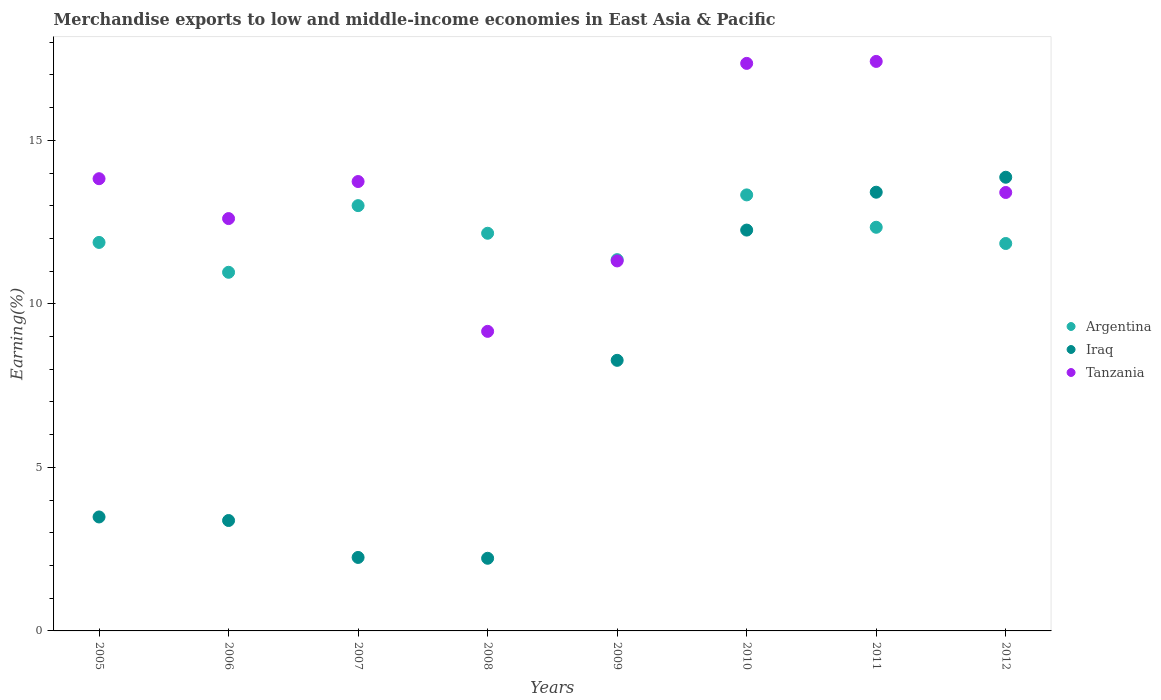Is the number of dotlines equal to the number of legend labels?
Keep it short and to the point. Yes. What is the percentage of amount earned from merchandise exports in Argentina in 2011?
Your answer should be very brief. 12.34. Across all years, what is the maximum percentage of amount earned from merchandise exports in Tanzania?
Provide a short and direct response. 17.41. Across all years, what is the minimum percentage of amount earned from merchandise exports in Iraq?
Your answer should be compact. 2.22. What is the total percentage of amount earned from merchandise exports in Tanzania in the graph?
Offer a terse response. 108.83. What is the difference between the percentage of amount earned from merchandise exports in Tanzania in 2009 and that in 2010?
Give a very brief answer. -6.04. What is the difference between the percentage of amount earned from merchandise exports in Argentina in 2005 and the percentage of amount earned from merchandise exports in Iraq in 2009?
Your answer should be very brief. 3.61. What is the average percentage of amount earned from merchandise exports in Tanzania per year?
Offer a terse response. 13.6. In the year 2011, what is the difference between the percentage of amount earned from merchandise exports in Tanzania and percentage of amount earned from merchandise exports in Iraq?
Keep it short and to the point. 4. What is the ratio of the percentage of amount earned from merchandise exports in Tanzania in 2008 to that in 2011?
Provide a succinct answer. 0.53. Is the difference between the percentage of amount earned from merchandise exports in Tanzania in 2009 and 2010 greater than the difference between the percentage of amount earned from merchandise exports in Iraq in 2009 and 2010?
Offer a very short reply. No. What is the difference between the highest and the second highest percentage of amount earned from merchandise exports in Argentina?
Give a very brief answer. 0.33. What is the difference between the highest and the lowest percentage of amount earned from merchandise exports in Tanzania?
Give a very brief answer. 8.25. Is the sum of the percentage of amount earned from merchandise exports in Tanzania in 2006 and 2008 greater than the maximum percentage of amount earned from merchandise exports in Iraq across all years?
Your answer should be compact. Yes. Is it the case that in every year, the sum of the percentage of amount earned from merchandise exports in Tanzania and percentage of amount earned from merchandise exports in Iraq  is greater than the percentage of amount earned from merchandise exports in Argentina?
Offer a terse response. No. Is the percentage of amount earned from merchandise exports in Argentina strictly less than the percentage of amount earned from merchandise exports in Tanzania over the years?
Keep it short and to the point. No. How many dotlines are there?
Your response must be concise. 3. Does the graph contain any zero values?
Offer a terse response. No. Does the graph contain grids?
Give a very brief answer. No. How many legend labels are there?
Provide a succinct answer. 3. How are the legend labels stacked?
Make the answer very short. Vertical. What is the title of the graph?
Keep it short and to the point. Merchandise exports to low and middle-income economies in East Asia & Pacific. What is the label or title of the X-axis?
Provide a short and direct response. Years. What is the label or title of the Y-axis?
Offer a very short reply. Earning(%). What is the Earning(%) in Argentina in 2005?
Provide a succinct answer. 11.88. What is the Earning(%) of Iraq in 2005?
Your response must be concise. 3.48. What is the Earning(%) in Tanzania in 2005?
Ensure brevity in your answer.  13.83. What is the Earning(%) of Argentina in 2006?
Provide a succinct answer. 10.97. What is the Earning(%) of Iraq in 2006?
Your response must be concise. 3.38. What is the Earning(%) in Tanzania in 2006?
Offer a very short reply. 12.61. What is the Earning(%) of Argentina in 2007?
Offer a terse response. 13. What is the Earning(%) in Iraq in 2007?
Your answer should be compact. 2.25. What is the Earning(%) in Tanzania in 2007?
Your answer should be very brief. 13.74. What is the Earning(%) of Argentina in 2008?
Give a very brief answer. 12.16. What is the Earning(%) in Iraq in 2008?
Provide a succinct answer. 2.22. What is the Earning(%) in Tanzania in 2008?
Give a very brief answer. 9.16. What is the Earning(%) of Argentina in 2009?
Give a very brief answer. 11.35. What is the Earning(%) in Iraq in 2009?
Provide a succinct answer. 8.27. What is the Earning(%) in Tanzania in 2009?
Your response must be concise. 11.31. What is the Earning(%) in Argentina in 2010?
Give a very brief answer. 13.33. What is the Earning(%) in Iraq in 2010?
Provide a succinct answer. 12.26. What is the Earning(%) of Tanzania in 2010?
Provide a succinct answer. 17.35. What is the Earning(%) of Argentina in 2011?
Your answer should be compact. 12.34. What is the Earning(%) of Iraq in 2011?
Offer a terse response. 13.41. What is the Earning(%) of Tanzania in 2011?
Ensure brevity in your answer.  17.41. What is the Earning(%) of Argentina in 2012?
Your answer should be compact. 11.85. What is the Earning(%) in Iraq in 2012?
Offer a terse response. 13.87. What is the Earning(%) of Tanzania in 2012?
Keep it short and to the point. 13.41. Across all years, what is the maximum Earning(%) of Argentina?
Your answer should be compact. 13.33. Across all years, what is the maximum Earning(%) of Iraq?
Keep it short and to the point. 13.87. Across all years, what is the maximum Earning(%) in Tanzania?
Provide a succinct answer. 17.41. Across all years, what is the minimum Earning(%) in Argentina?
Your answer should be very brief. 10.97. Across all years, what is the minimum Earning(%) in Iraq?
Provide a short and direct response. 2.22. Across all years, what is the minimum Earning(%) of Tanzania?
Make the answer very short. 9.16. What is the total Earning(%) of Argentina in the graph?
Your answer should be very brief. 96.89. What is the total Earning(%) in Iraq in the graph?
Keep it short and to the point. 59.15. What is the total Earning(%) of Tanzania in the graph?
Your answer should be very brief. 108.83. What is the difference between the Earning(%) in Argentina in 2005 and that in 2006?
Provide a short and direct response. 0.91. What is the difference between the Earning(%) in Iraq in 2005 and that in 2006?
Give a very brief answer. 0.11. What is the difference between the Earning(%) of Tanzania in 2005 and that in 2006?
Ensure brevity in your answer.  1.22. What is the difference between the Earning(%) of Argentina in 2005 and that in 2007?
Your answer should be very brief. -1.13. What is the difference between the Earning(%) in Iraq in 2005 and that in 2007?
Provide a short and direct response. 1.24. What is the difference between the Earning(%) in Tanzania in 2005 and that in 2007?
Offer a terse response. 0.09. What is the difference between the Earning(%) in Argentina in 2005 and that in 2008?
Ensure brevity in your answer.  -0.28. What is the difference between the Earning(%) in Iraq in 2005 and that in 2008?
Provide a succinct answer. 1.26. What is the difference between the Earning(%) of Tanzania in 2005 and that in 2008?
Offer a very short reply. 4.67. What is the difference between the Earning(%) in Argentina in 2005 and that in 2009?
Offer a terse response. 0.53. What is the difference between the Earning(%) in Iraq in 2005 and that in 2009?
Offer a very short reply. -4.79. What is the difference between the Earning(%) in Tanzania in 2005 and that in 2009?
Your response must be concise. 2.51. What is the difference between the Earning(%) of Argentina in 2005 and that in 2010?
Offer a very short reply. -1.45. What is the difference between the Earning(%) in Iraq in 2005 and that in 2010?
Keep it short and to the point. -8.77. What is the difference between the Earning(%) of Tanzania in 2005 and that in 2010?
Provide a succinct answer. -3.53. What is the difference between the Earning(%) in Argentina in 2005 and that in 2011?
Ensure brevity in your answer.  -0.46. What is the difference between the Earning(%) in Iraq in 2005 and that in 2011?
Your response must be concise. -9.93. What is the difference between the Earning(%) of Tanzania in 2005 and that in 2011?
Your response must be concise. -3.59. What is the difference between the Earning(%) of Argentina in 2005 and that in 2012?
Keep it short and to the point. 0.03. What is the difference between the Earning(%) in Iraq in 2005 and that in 2012?
Your response must be concise. -10.39. What is the difference between the Earning(%) of Tanzania in 2005 and that in 2012?
Your answer should be compact. 0.42. What is the difference between the Earning(%) of Argentina in 2006 and that in 2007?
Ensure brevity in your answer.  -2.04. What is the difference between the Earning(%) of Iraq in 2006 and that in 2007?
Ensure brevity in your answer.  1.13. What is the difference between the Earning(%) in Tanzania in 2006 and that in 2007?
Your answer should be compact. -1.13. What is the difference between the Earning(%) of Argentina in 2006 and that in 2008?
Offer a very short reply. -1.19. What is the difference between the Earning(%) in Iraq in 2006 and that in 2008?
Provide a succinct answer. 1.15. What is the difference between the Earning(%) of Tanzania in 2006 and that in 2008?
Give a very brief answer. 3.45. What is the difference between the Earning(%) of Argentina in 2006 and that in 2009?
Offer a terse response. -0.39. What is the difference between the Earning(%) in Iraq in 2006 and that in 2009?
Provide a succinct answer. -4.9. What is the difference between the Earning(%) of Tanzania in 2006 and that in 2009?
Your response must be concise. 1.3. What is the difference between the Earning(%) of Argentina in 2006 and that in 2010?
Keep it short and to the point. -2.37. What is the difference between the Earning(%) in Iraq in 2006 and that in 2010?
Give a very brief answer. -8.88. What is the difference between the Earning(%) of Tanzania in 2006 and that in 2010?
Your answer should be very brief. -4.75. What is the difference between the Earning(%) of Argentina in 2006 and that in 2011?
Give a very brief answer. -1.38. What is the difference between the Earning(%) in Iraq in 2006 and that in 2011?
Your answer should be very brief. -10.04. What is the difference between the Earning(%) in Tanzania in 2006 and that in 2011?
Your answer should be compact. -4.81. What is the difference between the Earning(%) in Argentina in 2006 and that in 2012?
Your answer should be very brief. -0.88. What is the difference between the Earning(%) of Iraq in 2006 and that in 2012?
Offer a terse response. -10.5. What is the difference between the Earning(%) of Tanzania in 2006 and that in 2012?
Make the answer very short. -0.8. What is the difference between the Earning(%) of Argentina in 2007 and that in 2008?
Make the answer very short. 0.84. What is the difference between the Earning(%) of Iraq in 2007 and that in 2008?
Keep it short and to the point. 0.03. What is the difference between the Earning(%) of Tanzania in 2007 and that in 2008?
Give a very brief answer. 4.58. What is the difference between the Earning(%) in Argentina in 2007 and that in 2009?
Offer a terse response. 1.65. What is the difference between the Earning(%) of Iraq in 2007 and that in 2009?
Your response must be concise. -6.03. What is the difference between the Earning(%) in Tanzania in 2007 and that in 2009?
Offer a terse response. 2.43. What is the difference between the Earning(%) of Argentina in 2007 and that in 2010?
Keep it short and to the point. -0.33. What is the difference between the Earning(%) in Iraq in 2007 and that in 2010?
Offer a terse response. -10.01. What is the difference between the Earning(%) of Tanzania in 2007 and that in 2010?
Give a very brief answer. -3.61. What is the difference between the Earning(%) of Argentina in 2007 and that in 2011?
Offer a very short reply. 0.66. What is the difference between the Earning(%) of Iraq in 2007 and that in 2011?
Offer a very short reply. -11.17. What is the difference between the Earning(%) in Tanzania in 2007 and that in 2011?
Offer a very short reply. -3.67. What is the difference between the Earning(%) in Argentina in 2007 and that in 2012?
Provide a succinct answer. 1.16. What is the difference between the Earning(%) in Iraq in 2007 and that in 2012?
Keep it short and to the point. -11.63. What is the difference between the Earning(%) in Tanzania in 2007 and that in 2012?
Your answer should be very brief. 0.33. What is the difference between the Earning(%) of Argentina in 2008 and that in 2009?
Provide a succinct answer. 0.81. What is the difference between the Earning(%) in Iraq in 2008 and that in 2009?
Offer a terse response. -6.05. What is the difference between the Earning(%) in Tanzania in 2008 and that in 2009?
Your answer should be compact. -2.15. What is the difference between the Earning(%) in Argentina in 2008 and that in 2010?
Keep it short and to the point. -1.17. What is the difference between the Earning(%) of Iraq in 2008 and that in 2010?
Your answer should be compact. -10.04. What is the difference between the Earning(%) of Tanzania in 2008 and that in 2010?
Provide a short and direct response. -8.19. What is the difference between the Earning(%) in Argentina in 2008 and that in 2011?
Keep it short and to the point. -0.18. What is the difference between the Earning(%) in Iraq in 2008 and that in 2011?
Offer a very short reply. -11.19. What is the difference between the Earning(%) of Tanzania in 2008 and that in 2011?
Your answer should be very brief. -8.25. What is the difference between the Earning(%) in Argentina in 2008 and that in 2012?
Give a very brief answer. 0.31. What is the difference between the Earning(%) in Iraq in 2008 and that in 2012?
Keep it short and to the point. -11.65. What is the difference between the Earning(%) in Tanzania in 2008 and that in 2012?
Ensure brevity in your answer.  -4.25. What is the difference between the Earning(%) in Argentina in 2009 and that in 2010?
Your response must be concise. -1.98. What is the difference between the Earning(%) of Iraq in 2009 and that in 2010?
Offer a terse response. -3.98. What is the difference between the Earning(%) in Tanzania in 2009 and that in 2010?
Provide a succinct answer. -6.04. What is the difference between the Earning(%) in Argentina in 2009 and that in 2011?
Your response must be concise. -0.99. What is the difference between the Earning(%) of Iraq in 2009 and that in 2011?
Offer a very short reply. -5.14. What is the difference between the Earning(%) of Tanzania in 2009 and that in 2011?
Ensure brevity in your answer.  -6.1. What is the difference between the Earning(%) of Argentina in 2009 and that in 2012?
Ensure brevity in your answer.  -0.49. What is the difference between the Earning(%) of Iraq in 2009 and that in 2012?
Your answer should be very brief. -5.6. What is the difference between the Earning(%) of Tanzania in 2009 and that in 2012?
Your answer should be compact. -2.09. What is the difference between the Earning(%) of Iraq in 2010 and that in 2011?
Your response must be concise. -1.16. What is the difference between the Earning(%) in Tanzania in 2010 and that in 2011?
Your answer should be compact. -0.06. What is the difference between the Earning(%) of Argentina in 2010 and that in 2012?
Your response must be concise. 1.49. What is the difference between the Earning(%) in Iraq in 2010 and that in 2012?
Give a very brief answer. -1.62. What is the difference between the Earning(%) of Tanzania in 2010 and that in 2012?
Provide a short and direct response. 3.95. What is the difference between the Earning(%) of Argentina in 2011 and that in 2012?
Make the answer very short. 0.5. What is the difference between the Earning(%) of Iraq in 2011 and that in 2012?
Your answer should be very brief. -0.46. What is the difference between the Earning(%) in Tanzania in 2011 and that in 2012?
Keep it short and to the point. 4.01. What is the difference between the Earning(%) of Argentina in 2005 and the Earning(%) of Iraq in 2006?
Your answer should be compact. 8.5. What is the difference between the Earning(%) in Argentina in 2005 and the Earning(%) in Tanzania in 2006?
Your answer should be very brief. -0.73. What is the difference between the Earning(%) of Iraq in 2005 and the Earning(%) of Tanzania in 2006?
Provide a succinct answer. -9.12. What is the difference between the Earning(%) of Argentina in 2005 and the Earning(%) of Iraq in 2007?
Offer a terse response. 9.63. What is the difference between the Earning(%) of Argentina in 2005 and the Earning(%) of Tanzania in 2007?
Ensure brevity in your answer.  -1.86. What is the difference between the Earning(%) of Iraq in 2005 and the Earning(%) of Tanzania in 2007?
Your answer should be very brief. -10.26. What is the difference between the Earning(%) of Argentina in 2005 and the Earning(%) of Iraq in 2008?
Your answer should be compact. 9.66. What is the difference between the Earning(%) in Argentina in 2005 and the Earning(%) in Tanzania in 2008?
Keep it short and to the point. 2.72. What is the difference between the Earning(%) of Iraq in 2005 and the Earning(%) of Tanzania in 2008?
Your answer should be very brief. -5.68. What is the difference between the Earning(%) in Argentina in 2005 and the Earning(%) in Iraq in 2009?
Offer a terse response. 3.61. What is the difference between the Earning(%) of Argentina in 2005 and the Earning(%) of Tanzania in 2009?
Offer a terse response. 0.57. What is the difference between the Earning(%) in Iraq in 2005 and the Earning(%) in Tanzania in 2009?
Provide a succinct answer. -7.83. What is the difference between the Earning(%) in Argentina in 2005 and the Earning(%) in Iraq in 2010?
Your response must be concise. -0.38. What is the difference between the Earning(%) of Argentina in 2005 and the Earning(%) of Tanzania in 2010?
Your response must be concise. -5.47. What is the difference between the Earning(%) in Iraq in 2005 and the Earning(%) in Tanzania in 2010?
Give a very brief answer. -13.87. What is the difference between the Earning(%) in Argentina in 2005 and the Earning(%) in Iraq in 2011?
Your response must be concise. -1.54. What is the difference between the Earning(%) in Argentina in 2005 and the Earning(%) in Tanzania in 2011?
Give a very brief answer. -5.53. What is the difference between the Earning(%) in Iraq in 2005 and the Earning(%) in Tanzania in 2011?
Provide a short and direct response. -13.93. What is the difference between the Earning(%) in Argentina in 2005 and the Earning(%) in Iraq in 2012?
Your response must be concise. -1.99. What is the difference between the Earning(%) in Argentina in 2005 and the Earning(%) in Tanzania in 2012?
Give a very brief answer. -1.53. What is the difference between the Earning(%) of Iraq in 2005 and the Earning(%) of Tanzania in 2012?
Provide a succinct answer. -9.92. What is the difference between the Earning(%) in Argentina in 2006 and the Earning(%) in Iraq in 2007?
Offer a very short reply. 8.72. What is the difference between the Earning(%) in Argentina in 2006 and the Earning(%) in Tanzania in 2007?
Make the answer very short. -2.77. What is the difference between the Earning(%) in Iraq in 2006 and the Earning(%) in Tanzania in 2007?
Your answer should be very brief. -10.37. What is the difference between the Earning(%) of Argentina in 2006 and the Earning(%) of Iraq in 2008?
Keep it short and to the point. 8.75. What is the difference between the Earning(%) of Argentina in 2006 and the Earning(%) of Tanzania in 2008?
Offer a very short reply. 1.81. What is the difference between the Earning(%) in Iraq in 2006 and the Earning(%) in Tanzania in 2008?
Make the answer very short. -5.78. What is the difference between the Earning(%) of Argentina in 2006 and the Earning(%) of Iraq in 2009?
Provide a short and direct response. 2.69. What is the difference between the Earning(%) in Argentina in 2006 and the Earning(%) in Tanzania in 2009?
Your answer should be compact. -0.35. What is the difference between the Earning(%) of Iraq in 2006 and the Earning(%) of Tanzania in 2009?
Your response must be concise. -7.94. What is the difference between the Earning(%) in Argentina in 2006 and the Earning(%) in Iraq in 2010?
Provide a short and direct response. -1.29. What is the difference between the Earning(%) of Argentina in 2006 and the Earning(%) of Tanzania in 2010?
Keep it short and to the point. -6.39. What is the difference between the Earning(%) in Iraq in 2006 and the Earning(%) in Tanzania in 2010?
Offer a terse response. -13.98. What is the difference between the Earning(%) of Argentina in 2006 and the Earning(%) of Iraq in 2011?
Offer a very short reply. -2.45. What is the difference between the Earning(%) of Argentina in 2006 and the Earning(%) of Tanzania in 2011?
Provide a succinct answer. -6.45. What is the difference between the Earning(%) in Iraq in 2006 and the Earning(%) in Tanzania in 2011?
Keep it short and to the point. -14.04. What is the difference between the Earning(%) of Argentina in 2006 and the Earning(%) of Iraq in 2012?
Give a very brief answer. -2.91. What is the difference between the Earning(%) in Argentina in 2006 and the Earning(%) in Tanzania in 2012?
Your answer should be very brief. -2.44. What is the difference between the Earning(%) in Iraq in 2006 and the Earning(%) in Tanzania in 2012?
Give a very brief answer. -10.03. What is the difference between the Earning(%) of Argentina in 2007 and the Earning(%) of Iraq in 2008?
Make the answer very short. 10.78. What is the difference between the Earning(%) in Argentina in 2007 and the Earning(%) in Tanzania in 2008?
Give a very brief answer. 3.84. What is the difference between the Earning(%) of Iraq in 2007 and the Earning(%) of Tanzania in 2008?
Ensure brevity in your answer.  -6.91. What is the difference between the Earning(%) of Argentina in 2007 and the Earning(%) of Iraq in 2009?
Offer a terse response. 4.73. What is the difference between the Earning(%) in Argentina in 2007 and the Earning(%) in Tanzania in 2009?
Provide a succinct answer. 1.69. What is the difference between the Earning(%) in Iraq in 2007 and the Earning(%) in Tanzania in 2009?
Keep it short and to the point. -9.07. What is the difference between the Earning(%) in Argentina in 2007 and the Earning(%) in Iraq in 2010?
Your answer should be very brief. 0.75. What is the difference between the Earning(%) in Argentina in 2007 and the Earning(%) in Tanzania in 2010?
Ensure brevity in your answer.  -4.35. What is the difference between the Earning(%) of Iraq in 2007 and the Earning(%) of Tanzania in 2010?
Offer a terse response. -15.11. What is the difference between the Earning(%) of Argentina in 2007 and the Earning(%) of Iraq in 2011?
Give a very brief answer. -0.41. What is the difference between the Earning(%) of Argentina in 2007 and the Earning(%) of Tanzania in 2011?
Give a very brief answer. -4.41. What is the difference between the Earning(%) in Iraq in 2007 and the Earning(%) in Tanzania in 2011?
Provide a succinct answer. -15.17. What is the difference between the Earning(%) in Argentina in 2007 and the Earning(%) in Iraq in 2012?
Offer a very short reply. -0.87. What is the difference between the Earning(%) of Argentina in 2007 and the Earning(%) of Tanzania in 2012?
Offer a terse response. -0.4. What is the difference between the Earning(%) in Iraq in 2007 and the Earning(%) in Tanzania in 2012?
Your response must be concise. -11.16. What is the difference between the Earning(%) in Argentina in 2008 and the Earning(%) in Iraq in 2009?
Keep it short and to the point. 3.89. What is the difference between the Earning(%) in Argentina in 2008 and the Earning(%) in Tanzania in 2009?
Your answer should be compact. 0.85. What is the difference between the Earning(%) in Iraq in 2008 and the Earning(%) in Tanzania in 2009?
Offer a very short reply. -9.09. What is the difference between the Earning(%) of Argentina in 2008 and the Earning(%) of Iraq in 2010?
Your answer should be very brief. -0.1. What is the difference between the Earning(%) in Argentina in 2008 and the Earning(%) in Tanzania in 2010?
Your response must be concise. -5.19. What is the difference between the Earning(%) of Iraq in 2008 and the Earning(%) of Tanzania in 2010?
Provide a succinct answer. -15.13. What is the difference between the Earning(%) in Argentina in 2008 and the Earning(%) in Iraq in 2011?
Your answer should be compact. -1.25. What is the difference between the Earning(%) in Argentina in 2008 and the Earning(%) in Tanzania in 2011?
Ensure brevity in your answer.  -5.25. What is the difference between the Earning(%) of Iraq in 2008 and the Earning(%) of Tanzania in 2011?
Your response must be concise. -15.19. What is the difference between the Earning(%) of Argentina in 2008 and the Earning(%) of Iraq in 2012?
Your answer should be compact. -1.71. What is the difference between the Earning(%) of Argentina in 2008 and the Earning(%) of Tanzania in 2012?
Make the answer very short. -1.25. What is the difference between the Earning(%) in Iraq in 2008 and the Earning(%) in Tanzania in 2012?
Your answer should be very brief. -11.19. What is the difference between the Earning(%) in Argentina in 2009 and the Earning(%) in Iraq in 2010?
Give a very brief answer. -0.9. What is the difference between the Earning(%) of Argentina in 2009 and the Earning(%) of Tanzania in 2010?
Offer a terse response. -6. What is the difference between the Earning(%) of Iraq in 2009 and the Earning(%) of Tanzania in 2010?
Keep it short and to the point. -9.08. What is the difference between the Earning(%) in Argentina in 2009 and the Earning(%) in Iraq in 2011?
Give a very brief answer. -2.06. What is the difference between the Earning(%) of Argentina in 2009 and the Earning(%) of Tanzania in 2011?
Offer a very short reply. -6.06. What is the difference between the Earning(%) in Iraq in 2009 and the Earning(%) in Tanzania in 2011?
Make the answer very short. -9.14. What is the difference between the Earning(%) in Argentina in 2009 and the Earning(%) in Iraq in 2012?
Make the answer very short. -2.52. What is the difference between the Earning(%) in Argentina in 2009 and the Earning(%) in Tanzania in 2012?
Provide a short and direct response. -2.05. What is the difference between the Earning(%) of Iraq in 2009 and the Earning(%) of Tanzania in 2012?
Ensure brevity in your answer.  -5.13. What is the difference between the Earning(%) of Argentina in 2010 and the Earning(%) of Iraq in 2011?
Your answer should be very brief. -0.08. What is the difference between the Earning(%) in Argentina in 2010 and the Earning(%) in Tanzania in 2011?
Your answer should be very brief. -4.08. What is the difference between the Earning(%) in Iraq in 2010 and the Earning(%) in Tanzania in 2011?
Your answer should be very brief. -5.16. What is the difference between the Earning(%) in Argentina in 2010 and the Earning(%) in Iraq in 2012?
Give a very brief answer. -0.54. What is the difference between the Earning(%) in Argentina in 2010 and the Earning(%) in Tanzania in 2012?
Offer a very short reply. -0.07. What is the difference between the Earning(%) in Iraq in 2010 and the Earning(%) in Tanzania in 2012?
Make the answer very short. -1.15. What is the difference between the Earning(%) of Argentina in 2011 and the Earning(%) of Iraq in 2012?
Ensure brevity in your answer.  -1.53. What is the difference between the Earning(%) in Argentina in 2011 and the Earning(%) in Tanzania in 2012?
Offer a terse response. -1.06. What is the difference between the Earning(%) of Iraq in 2011 and the Earning(%) of Tanzania in 2012?
Keep it short and to the point. 0.01. What is the average Earning(%) in Argentina per year?
Ensure brevity in your answer.  12.11. What is the average Earning(%) in Iraq per year?
Ensure brevity in your answer.  7.39. What is the average Earning(%) of Tanzania per year?
Give a very brief answer. 13.6. In the year 2005, what is the difference between the Earning(%) of Argentina and Earning(%) of Iraq?
Your answer should be very brief. 8.39. In the year 2005, what is the difference between the Earning(%) of Argentina and Earning(%) of Tanzania?
Keep it short and to the point. -1.95. In the year 2005, what is the difference between the Earning(%) of Iraq and Earning(%) of Tanzania?
Provide a succinct answer. -10.34. In the year 2006, what is the difference between the Earning(%) in Argentina and Earning(%) in Iraq?
Offer a very short reply. 7.59. In the year 2006, what is the difference between the Earning(%) of Argentina and Earning(%) of Tanzania?
Your answer should be compact. -1.64. In the year 2006, what is the difference between the Earning(%) of Iraq and Earning(%) of Tanzania?
Ensure brevity in your answer.  -9.23. In the year 2007, what is the difference between the Earning(%) of Argentina and Earning(%) of Iraq?
Your answer should be very brief. 10.76. In the year 2007, what is the difference between the Earning(%) in Argentina and Earning(%) in Tanzania?
Keep it short and to the point. -0.74. In the year 2007, what is the difference between the Earning(%) in Iraq and Earning(%) in Tanzania?
Provide a succinct answer. -11.49. In the year 2008, what is the difference between the Earning(%) in Argentina and Earning(%) in Iraq?
Offer a terse response. 9.94. In the year 2008, what is the difference between the Earning(%) in Argentina and Earning(%) in Tanzania?
Keep it short and to the point. 3. In the year 2008, what is the difference between the Earning(%) in Iraq and Earning(%) in Tanzania?
Your answer should be very brief. -6.94. In the year 2009, what is the difference between the Earning(%) of Argentina and Earning(%) of Iraq?
Provide a short and direct response. 3.08. In the year 2009, what is the difference between the Earning(%) in Argentina and Earning(%) in Tanzania?
Offer a terse response. 0.04. In the year 2009, what is the difference between the Earning(%) in Iraq and Earning(%) in Tanzania?
Offer a terse response. -3.04. In the year 2010, what is the difference between the Earning(%) in Argentina and Earning(%) in Iraq?
Offer a very short reply. 1.08. In the year 2010, what is the difference between the Earning(%) in Argentina and Earning(%) in Tanzania?
Make the answer very short. -4.02. In the year 2010, what is the difference between the Earning(%) in Iraq and Earning(%) in Tanzania?
Offer a very short reply. -5.1. In the year 2011, what is the difference between the Earning(%) of Argentina and Earning(%) of Iraq?
Your response must be concise. -1.07. In the year 2011, what is the difference between the Earning(%) in Argentina and Earning(%) in Tanzania?
Provide a short and direct response. -5.07. In the year 2011, what is the difference between the Earning(%) of Iraq and Earning(%) of Tanzania?
Offer a very short reply. -4. In the year 2012, what is the difference between the Earning(%) of Argentina and Earning(%) of Iraq?
Offer a very short reply. -2.03. In the year 2012, what is the difference between the Earning(%) in Argentina and Earning(%) in Tanzania?
Offer a terse response. -1.56. In the year 2012, what is the difference between the Earning(%) in Iraq and Earning(%) in Tanzania?
Make the answer very short. 0.47. What is the ratio of the Earning(%) in Argentina in 2005 to that in 2006?
Your answer should be very brief. 1.08. What is the ratio of the Earning(%) in Iraq in 2005 to that in 2006?
Your answer should be very brief. 1.03. What is the ratio of the Earning(%) in Tanzania in 2005 to that in 2006?
Keep it short and to the point. 1.1. What is the ratio of the Earning(%) of Argentina in 2005 to that in 2007?
Give a very brief answer. 0.91. What is the ratio of the Earning(%) in Iraq in 2005 to that in 2007?
Offer a terse response. 1.55. What is the ratio of the Earning(%) in Argentina in 2005 to that in 2008?
Ensure brevity in your answer.  0.98. What is the ratio of the Earning(%) of Iraq in 2005 to that in 2008?
Your response must be concise. 1.57. What is the ratio of the Earning(%) of Tanzania in 2005 to that in 2008?
Your answer should be very brief. 1.51. What is the ratio of the Earning(%) of Argentina in 2005 to that in 2009?
Your response must be concise. 1.05. What is the ratio of the Earning(%) in Iraq in 2005 to that in 2009?
Your answer should be very brief. 0.42. What is the ratio of the Earning(%) in Tanzania in 2005 to that in 2009?
Give a very brief answer. 1.22. What is the ratio of the Earning(%) of Argentina in 2005 to that in 2010?
Your answer should be very brief. 0.89. What is the ratio of the Earning(%) in Iraq in 2005 to that in 2010?
Keep it short and to the point. 0.28. What is the ratio of the Earning(%) of Tanzania in 2005 to that in 2010?
Offer a very short reply. 0.8. What is the ratio of the Earning(%) of Argentina in 2005 to that in 2011?
Give a very brief answer. 0.96. What is the ratio of the Earning(%) of Iraq in 2005 to that in 2011?
Your answer should be compact. 0.26. What is the ratio of the Earning(%) of Tanzania in 2005 to that in 2011?
Give a very brief answer. 0.79. What is the ratio of the Earning(%) in Argentina in 2005 to that in 2012?
Your response must be concise. 1. What is the ratio of the Earning(%) in Iraq in 2005 to that in 2012?
Ensure brevity in your answer.  0.25. What is the ratio of the Earning(%) of Tanzania in 2005 to that in 2012?
Offer a terse response. 1.03. What is the ratio of the Earning(%) of Argentina in 2006 to that in 2007?
Give a very brief answer. 0.84. What is the ratio of the Earning(%) in Iraq in 2006 to that in 2007?
Keep it short and to the point. 1.5. What is the ratio of the Earning(%) of Tanzania in 2006 to that in 2007?
Give a very brief answer. 0.92. What is the ratio of the Earning(%) of Argentina in 2006 to that in 2008?
Provide a short and direct response. 0.9. What is the ratio of the Earning(%) in Iraq in 2006 to that in 2008?
Ensure brevity in your answer.  1.52. What is the ratio of the Earning(%) in Tanzania in 2006 to that in 2008?
Offer a very short reply. 1.38. What is the ratio of the Earning(%) of Argentina in 2006 to that in 2009?
Provide a succinct answer. 0.97. What is the ratio of the Earning(%) in Iraq in 2006 to that in 2009?
Your answer should be compact. 0.41. What is the ratio of the Earning(%) in Tanzania in 2006 to that in 2009?
Your answer should be compact. 1.11. What is the ratio of the Earning(%) of Argentina in 2006 to that in 2010?
Keep it short and to the point. 0.82. What is the ratio of the Earning(%) of Iraq in 2006 to that in 2010?
Provide a succinct answer. 0.28. What is the ratio of the Earning(%) in Tanzania in 2006 to that in 2010?
Your answer should be very brief. 0.73. What is the ratio of the Earning(%) in Argentina in 2006 to that in 2011?
Make the answer very short. 0.89. What is the ratio of the Earning(%) of Iraq in 2006 to that in 2011?
Offer a terse response. 0.25. What is the ratio of the Earning(%) of Tanzania in 2006 to that in 2011?
Ensure brevity in your answer.  0.72. What is the ratio of the Earning(%) in Argentina in 2006 to that in 2012?
Make the answer very short. 0.93. What is the ratio of the Earning(%) of Iraq in 2006 to that in 2012?
Offer a very short reply. 0.24. What is the ratio of the Earning(%) in Tanzania in 2006 to that in 2012?
Ensure brevity in your answer.  0.94. What is the ratio of the Earning(%) of Argentina in 2007 to that in 2008?
Offer a very short reply. 1.07. What is the ratio of the Earning(%) in Iraq in 2007 to that in 2008?
Ensure brevity in your answer.  1.01. What is the ratio of the Earning(%) in Tanzania in 2007 to that in 2008?
Give a very brief answer. 1.5. What is the ratio of the Earning(%) of Argentina in 2007 to that in 2009?
Provide a succinct answer. 1.15. What is the ratio of the Earning(%) in Iraq in 2007 to that in 2009?
Your response must be concise. 0.27. What is the ratio of the Earning(%) of Tanzania in 2007 to that in 2009?
Offer a very short reply. 1.21. What is the ratio of the Earning(%) of Argentina in 2007 to that in 2010?
Keep it short and to the point. 0.98. What is the ratio of the Earning(%) of Iraq in 2007 to that in 2010?
Provide a succinct answer. 0.18. What is the ratio of the Earning(%) in Tanzania in 2007 to that in 2010?
Keep it short and to the point. 0.79. What is the ratio of the Earning(%) in Argentina in 2007 to that in 2011?
Your answer should be compact. 1.05. What is the ratio of the Earning(%) in Iraq in 2007 to that in 2011?
Keep it short and to the point. 0.17. What is the ratio of the Earning(%) of Tanzania in 2007 to that in 2011?
Provide a succinct answer. 0.79. What is the ratio of the Earning(%) in Argentina in 2007 to that in 2012?
Your answer should be compact. 1.1. What is the ratio of the Earning(%) in Iraq in 2007 to that in 2012?
Offer a very short reply. 0.16. What is the ratio of the Earning(%) in Tanzania in 2007 to that in 2012?
Ensure brevity in your answer.  1.02. What is the ratio of the Earning(%) in Argentina in 2008 to that in 2009?
Provide a short and direct response. 1.07. What is the ratio of the Earning(%) of Iraq in 2008 to that in 2009?
Your response must be concise. 0.27. What is the ratio of the Earning(%) of Tanzania in 2008 to that in 2009?
Give a very brief answer. 0.81. What is the ratio of the Earning(%) in Argentina in 2008 to that in 2010?
Keep it short and to the point. 0.91. What is the ratio of the Earning(%) of Iraq in 2008 to that in 2010?
Your answer should be very brief. 0.18. What is the ratio of the Earning(%) in Tanzania in 2008 to that in 2010?
Your answer should be compact. 0.53. What is the ratio of the Earning(%) in Argentina in 2008 to that in 2011?
Make the answer very short. 0.99. What is the ratio of the Earning(%) in Iraq in 2008 to that in 2011?
Offer a very short reply. 0.17. What is the ratio of the Earning(%) of Tanzania in 2008 to that in 2011?
Give a very brief answer. 0.53. What is the ratio of the Earning(%) in Argentina in 2008 to that in 2012?
Keep it short and to the point. 1.03. What is the ratio of the Earning(%) of Iraq in 2008 to that in 2012?
Your response must be concise. 0.16. What is the ratio of the Earning(%) in Tanzania in 2008 to that in 2012?
Provide a succinct answer. 0.68. What is the ratio of the Earning(%) of Argentina in 2009 to that in 2010?
Make the answer very short. 0.85. What is the ratio of the Earning(%) of Iraq in 2009 to that in 2010?
Make the answer very short. 0.68. What is the ratio of the Earning(%) of Tanzania in 2009 to that in 2010?
Give a very brief answer. 0.65. What is the ratio of the Earning(%) in Argentina in 2009 to that in 2011?
Your response must be concise. 0.92. What is the ratio of the Earning(%) in Iraq in 2009 to that in 2011?
Give a very brief answer. 0.62. What is the ratio of the Earning(%) in Tanzania in 2009 to that in 2011?
Make the answer very short. 0.65. What is the ratio of the Earning(%) of Argentina in 2009 to that in 2012?
Your answer should be very brief. 0.96. What is the ratio of the Earning(%) of Iraq in 2009 to that in 2012?
Keep it short and to the point. 0.6. What is the ratio of the Earning(%) in Tanzania in 2009 to that in 2012?
Keep it short and to the point. 0.84. What is the ratio of the Earning(%) in Argentina in 2010 to that in 2011?
Offer a very short reply. 1.08. What is the ratio of the Earning(%) in Iraq in 2010 to that in 2011?
Your answer should be compact. 0.91. What is the ratio of the Earning(%) in Tanzania in 2010 to that in 2011?
Give a very brief answer. 1. What is the ratio of the Earning(%) of Argentina in 2010 to that in 2012?
Keep it short and to the point. 1.13. What is the ratio of the Earning(%) of Iraq in 2010 to that in 2012?
Give a very brief answer. 0.88. What is the ratio of the Earning(%) of Tanzania in 2010 to that in 2012?
Keep it short and to the point. 1.29. What is the ratio of the Earning(%) of Argentina in 2011 to that in 2012?
Provide a short and direct response. 1.04. What is the ratio of the Earning(%) in Iraq in 2011 to that in 2012?
Your response must be concise. 0.97. What is the ratio of the Earning(%) in Tanzania in 2011 to that in 2012?
Your answer should be compact. 1.3. What is the difference between the highest and the second highest Earning(%) in Argentina?
Give a very brief answer. 0.33. What is the difference between the highest and the second highest Earning(%) in Iraq?
Offer a very short reply. 0.46. What is the difference between the highest and the second highest Earning(%) in Tanzania?
Provide a short and direct response. 0.06. What is the difference between the highest and the lowest Earning(%) of Argentina?
Provide a short and direct response. 2.37. What is the difference between the highest and the lowest Earning(%) of Iraq?
Give a very brief answer. 11.65. What is the difference between the highest and the lowest Earning(%) in Tanzania?
Ensure brevity in your answer.  8.25. 